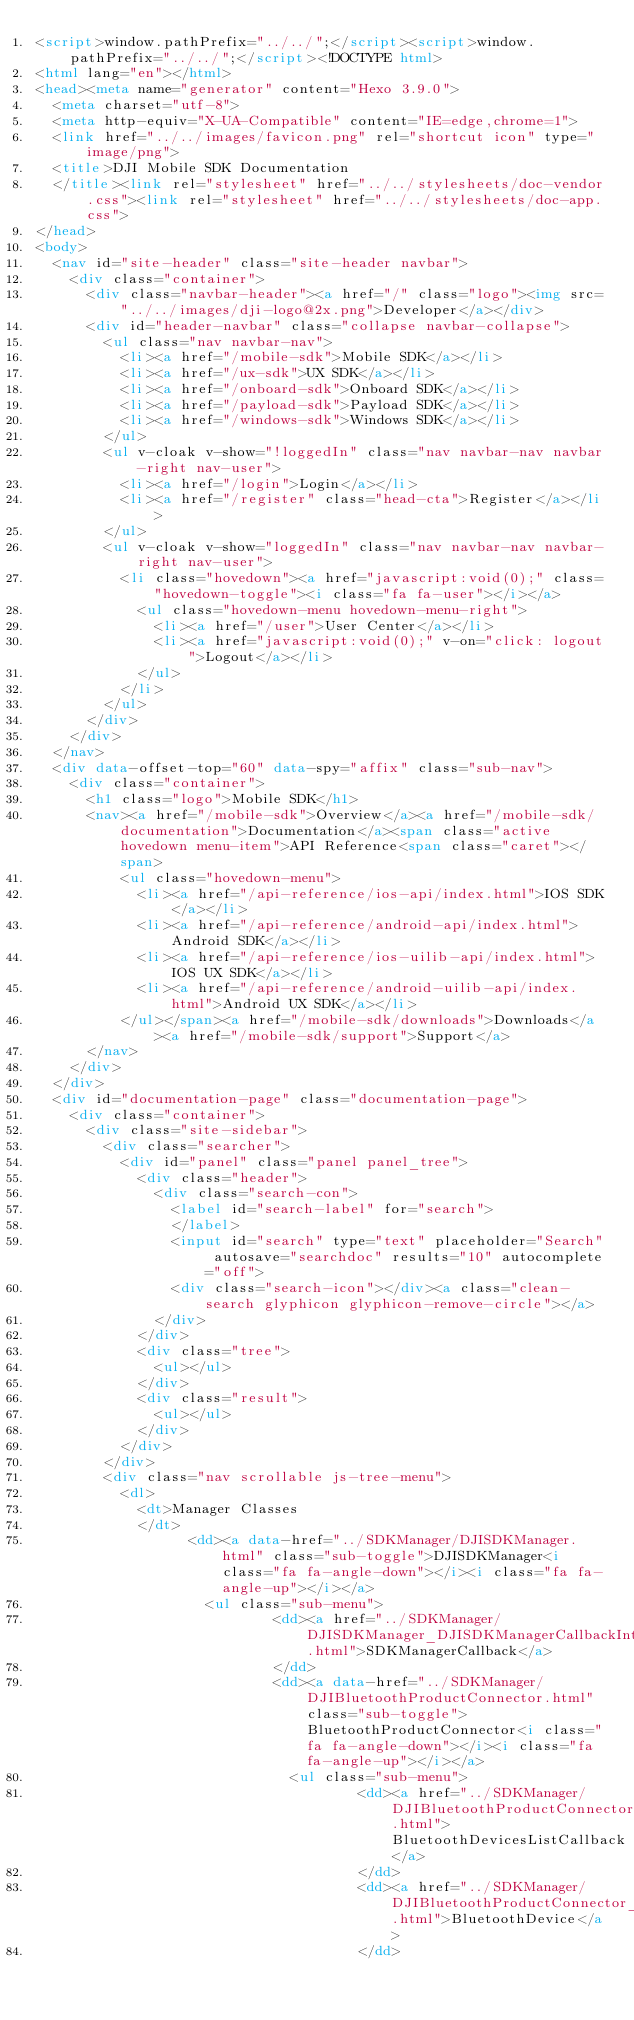Convert code to text. <code><loc_0><loc_0><loc_500><loc_500><_HTML_><script>window.pathPrefix="../../";</script><script>window.pathPrefix="../../";</script><!DOCTYPE html>
<html lang="en"></html>
<head><meta name="generator" content="Hexo 3.9.0">
  <meta charset="utf-8">
  <meta http-equiv="X-UA-Compatible" content="IE=edge,chrome=1">
  <link href="../../images/favicon.png" rel="shortcut icon" type="image/png">
  <title>DJI Mobile SDK Documentation
  </title><link rel="stylesheet" href="../../stylesheets/doc-vendor.css"><link rel="stylesheet" href="../../stylesheets/doc-app.css">
</head>
<body>
  <nav id="site-header" class="site-header navbar">
    <div class="container">
      <div class="navbar-header"><a href="/" class="logo"><img src="../../images/dji-logo@2x.png">Developer</a></div>
      <div id="header-navbar" class="collapse navbar-collapse">
        <ul class="nav navbar-nav">
          <li><a href="/mobile-sdk">Mobile SDK</a></li>
          <li><a href="/ux-sdk">UX SDK</a></li>
          <li><a href="/onboard-sdk">Onboard SDK</a></li>
          <li><a href="/payload-sdk">Payload SDK</a></li>
          <li><a href="/windows-sdk">Windows SDK</a></li>
        </ul>
        <ul v-cloak v-show="!loggedIn" class="nav navbar-nav navbar-right nav-user">
          <li><a href="/login">Login</a></li>
          <li><a href="/register" class="head-cta">Register</a></li>
        </ul>
        <ul v-cloak v-show="loggedIn" class="nav navbar-nav navbar-right nav-user">
          <li class="hovedown"><a href="javascript:void(0);" class="hovedown-toggle"><i class="fa fa-user"></i></a>
            <ul class="hovedown-menu hovedown-menu-right">
              <li><a href="/user">User Center</a></li>
              <li><a href="javascript:void(0);" v-on="click: logout">Logout</a></li>
            </ul>
          </li>
        </ul>
      </div>
    </div>
  </nav>
  <div data-offset-top="60" data-spy="affix" class="sub-nav">
    <div class="container">
      <h1 class="logo">Mobile SDK</h1>
      <nav><a href="/mobile-sdk">Overview</a><a href="/mobile-sdk/documentation">Documentation</a><span class="active hovedown menu-item">API Reference<span class="caret"></span>
          <ul class="hovedown-menu">
            <li><a href="/api-reference/ios-api/index.html">IOS SDK</a></li>
            <li><a href="/api-reference/android-api/index.html">Android SDK</a></li>
            <li><a href="/api-reference/ios-uilib-api/index.html">IOS UX SDK</a></li>
            <li><a href="/api-reference/android-uilib-api/index.html">Android UX SDK</a></li>
          </ul></span><a href="/mobile-sdk/downloads">Downloads</a><a href="/mobile-sdk/support">Support</a>
      </nav>
    </div>
  </div>
  <div id="documentation-page" class="documentation-page">
    <div class="container">
      <div class="site-sidebar">
        <div class="searcher">
          <div id="panel" class="panel panel_tree">
            <div class="header">
              <div class="search-con">
                <label id="search-label" for="search">
                </label>
                <input id="search" type="text" placeholder="Search" autosave="searchdoc" results="10" autocomplete="off">
                <div class="search-icon"></div><a class="clean-search glyphicon glyphicon-remove-circle"></a>
              </div>
            </div>
            <div class="tree">
              <ul></ul>
            </div>
            <div class="result">
              <ul></ul>
            </div>
          </div>
        </div>
        <div class="nav scrollable js-tree-menu">
          <dl>
            <dt>Manager Classes
            </dt>
                  <dd><a data-href="../SDKManager/DJISDKManager.html" class="sub-toggle">DJISDKManager<i class="fa fa-angle-down"></i><i class="fa fa-angle-up"></i></a>
                    <ul class="sub-menu">
                            <dd><a href="../SDKManager/DJISDKManager_DJISDKManagerCallbackInterface.html">SDKManagerCallback</a>
                            </dd>
                            <dd><a data-href="../SDKManager/DJIBluetoothProductConnector.html" class="sub-toggle">BluetoothProductConnector<i class="fa fa-angle-down"></i><i class="fa fa-angle-up"></i></a>
                              <ul class="sub-menu">
                                      <dd><a href="../SDKManager/DJIBluetoothProductConnector_BluetoothProductConnectorListenerInterface.html">BluetoothDevicesListCallback</a>
                                      </dd>
                                      <dd><a href="../SDKManager/DJIBluetoothProductConnector_DJIBluetoothDevice.html">BluetoothDevice</a>
                                      </dd></code> 